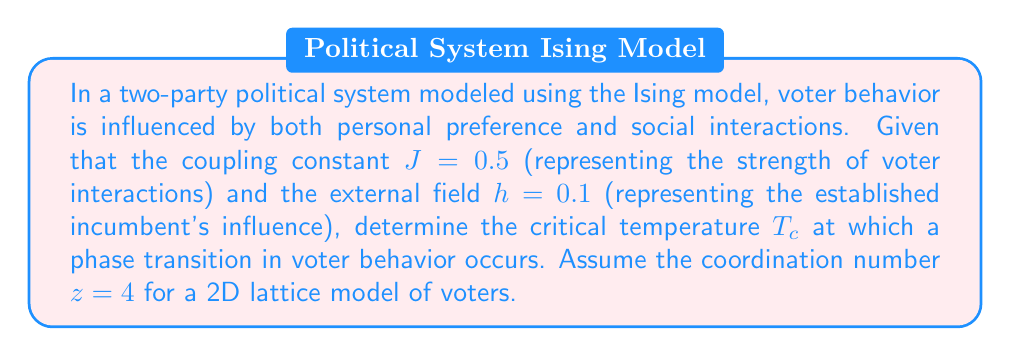Can you solve this math problem? To solve this problem, we'll use the mean-field approximation of the Ising model:

1. The mean-field critical temperature is given by:
   $$T_c = \frac{zJ}{k_B}$$
   where $z$ is the coordination number, $J$ is the coupling constant, and $k_B$ is the Boltzmann constant.

2. We are given:
   $z = 4$ (coordination number for 2D lattice)
   $J = 0.5$ (coupling constant)

3. For simplicity, we'll assume $k_B = 1$ (in appropriate units).

4. Substituting these values into the equation:
   $$T_c = \frac{4 \times 0.5}{1} = 2$$

5. The external field $h$ doesn't directly affect the critical temperature in the mean-field approximation, but it does influence the overall magnetization (voter preference) at all temperatures.

6. The phase transition occurs at $T_c = 2$, above which the system becomes disordered (voters are less influenced by their neighbors), and below which the system becomes ordered (voters tend to align with their neighbors).
Answer: $T_c = 2$ 